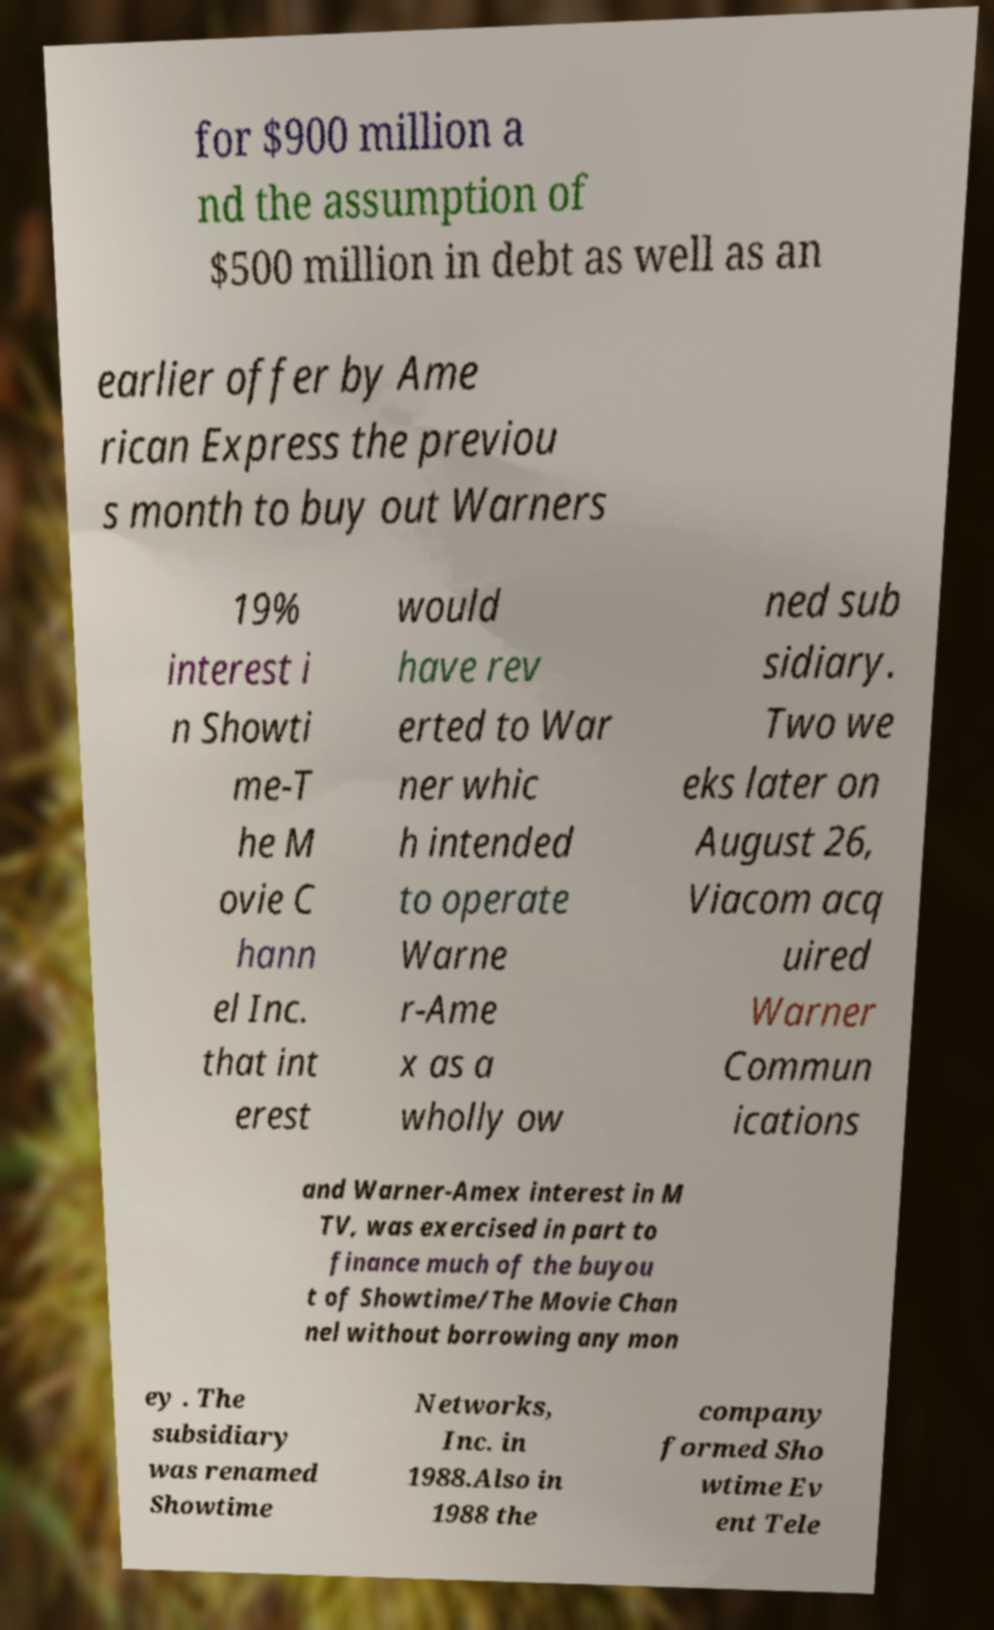Can you read and provide the text displayed in the image?This photo seems to have some interesting text. Can you extract and type it out for me? for $900 million a nd the assumption of $500 million in debt as well as an earlier offer by Ame rican Express the previou s month to buy out Warners 19% interest i n Showti me-T he M ovie C hann el Inc. that int erest would have rev erted to War ner whic h intended to operate Warne r-Ame x as a wholly ow ned sub sidiary. Two we eks later on August 26, Viacom acq uired Warner Commun ications and Warner-Amex interest in M TV, was exercised in part to finance much of the buyou t of Showtime/The Movie Chan nel without borrowing any mon ey . The subsidiary was renamed Showtime Networks, Inc. in 1988.Also in 1988 the company formed Sho wtime Ev ent Tele 